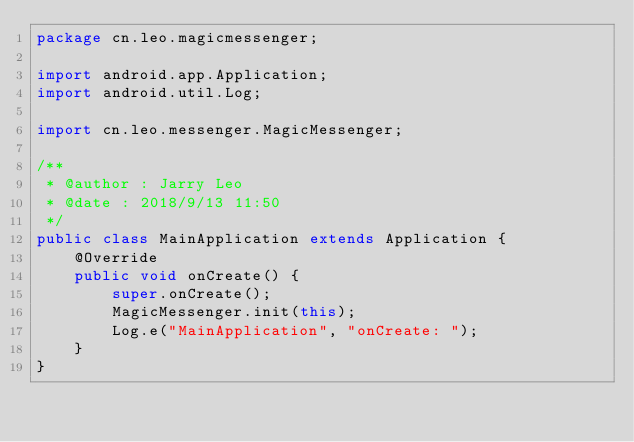Convert code to text. <code><loc_0><loc_0><loc_500><loc_500><_Java_>package cn.leo.magicmessenger;

import android.app.Application;
import android.util.Log;

import cn.leo.messenger.MagicMessenger;

/**
 * @author : Jarry Leo
 * @date : 2018/9/13 11:50
 */
public class MainApplication extends Application {
    @Override
    public void onCreate() {
        super.onCreate();
        MagicMessenger.init(this);
        Log.e("MainApplication", "onCreate: ");
    }
}
</code> 